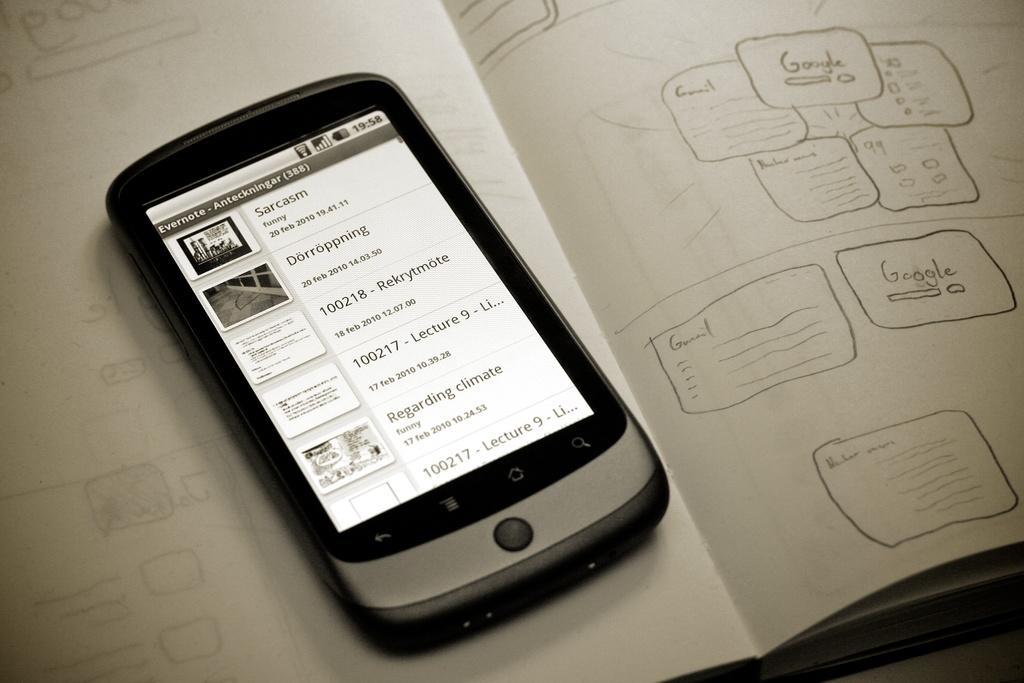<image>
Present a compact description of the photo's key features. the word sarcasm is on the white phone 